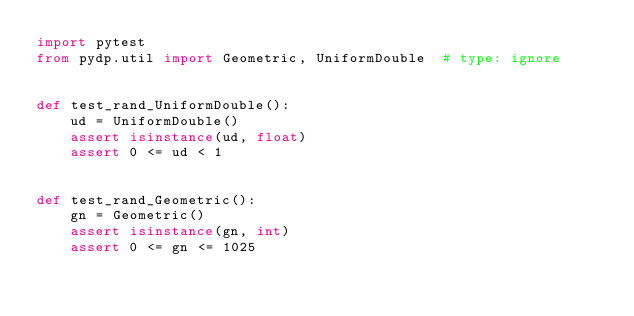Convert code to text. <code><loc_0><loc_0><loc_500><loc_500><_Python_>import pytest
from pydp.util import Geometric, UniformDouble  # type: ignore


def test_rand_UniformDouble():
    ud = UniformDouble()
    assert isinstance(ud, float)
    assert 0 <= ud < 1


def test_rand_Geometric():
    gn = Geometric()
    assert isinstance(gn, int)
    assert 0 <= gn <= 1025
</code> 